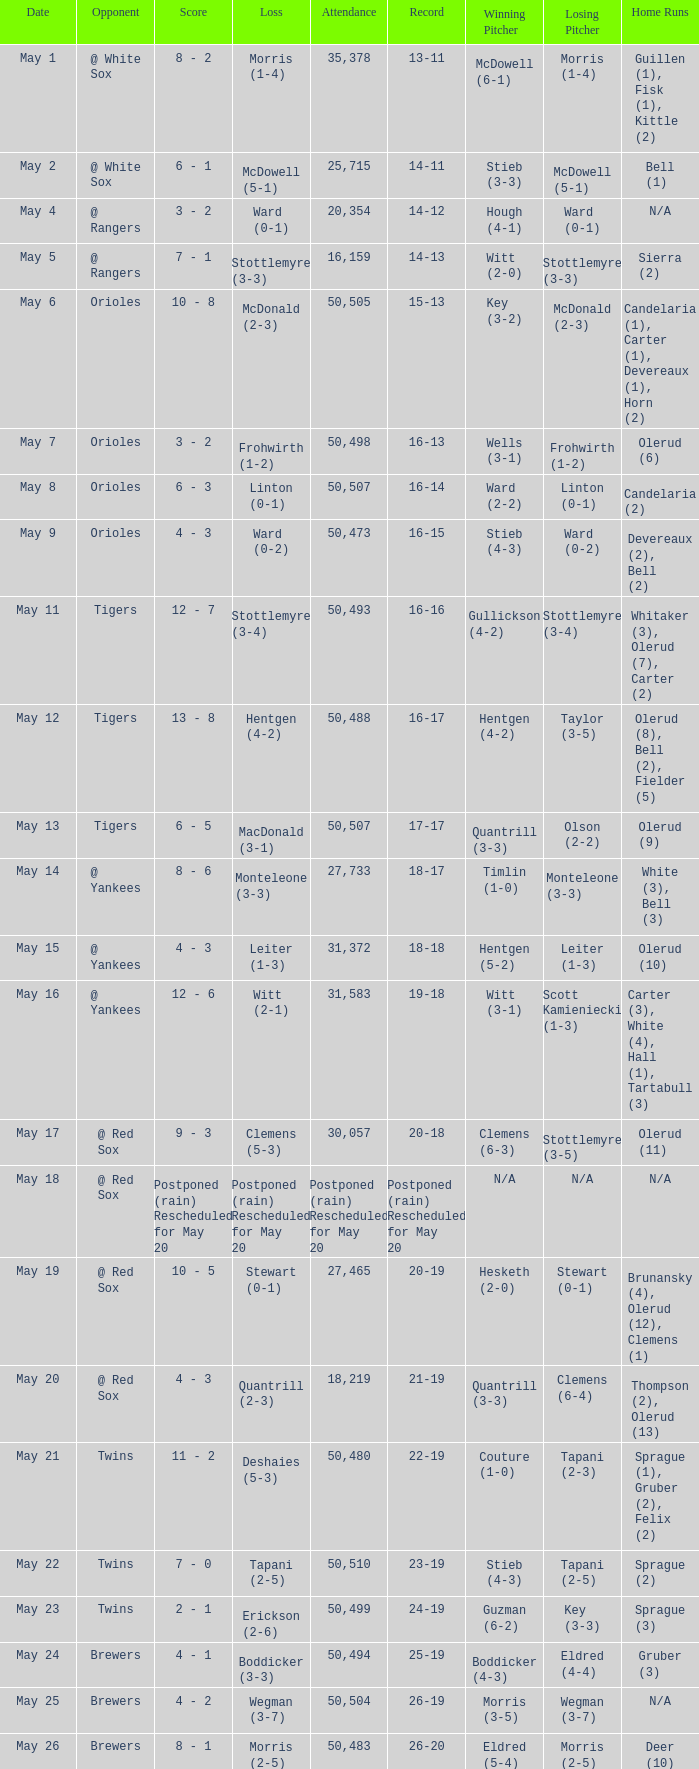What team did they lose to when they had a 28-22 record? Mohler (0-1). 